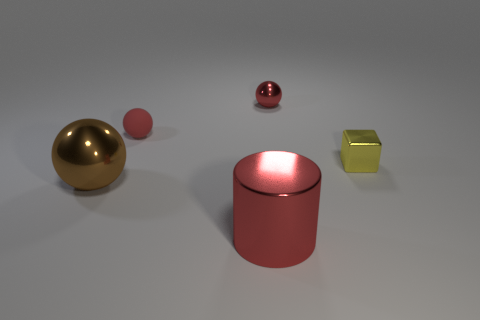Add 3 tiny shiny spheres. How many objects exist? 8 Subtract all cubes. How many objects are left? 4 Subtract 0 red cubes. How many objects are left? 5 Subtract all small purple metal objects. Subtract all small yellow objects. How many objects are left? 4 Add 4 brown shiny spheres. How many brown shiny spheres are left? 5 Add 2 blue rubber spheres. How many blue rubber spheres exist? 2 